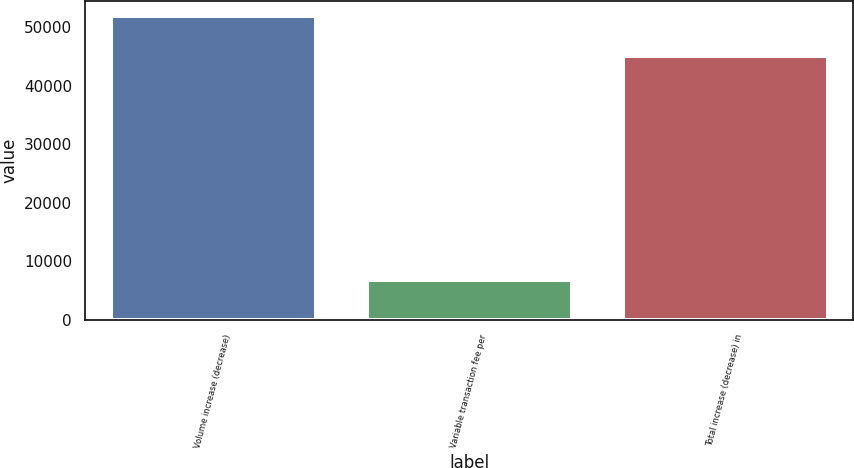<chart> <loc_0><loc_0><loc_500><loc_500><bar_chart><fcel>Volume increase (decrease)<fcel>Variable transaction fee per<fcel>Total increase (decrease) in<nl><fcel>51886<fcel>6854<fcel>45032<nl></chart> 